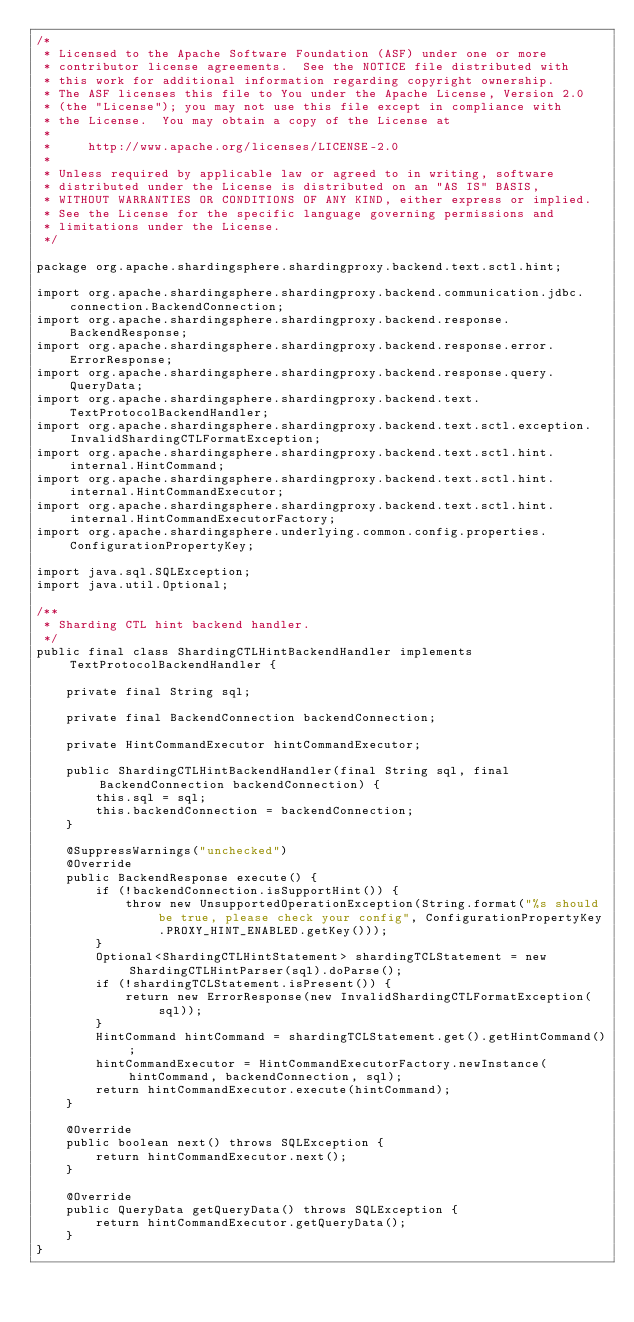Convert code to text. <code><loc_0><loc_0><loc_500><loc_500><_Java_>/*
 * Licensed to the Apache Software Foundation (ASF) under one or more
 * contributor license agreements.  See the NOTICE file distributed with
 * this work for additional information regarding copyright ownership.
 * The ASF licenses this file to You under the Apache License, Version 2.0
 * (the "License"); you may not use this file except in compliance with
 * the License.  You may obtain a copy of the License at
 *
 *     http://www.apache.org/licenses/LICENSE-2.0
 *
 * Unless required by applicable law or agreed to in writing, software
 * distributed under the License is distributed on an "AS IS" BASIS,
 * WITHOUT WARRANTIES OR CONDITIONS OF ANY KIND, either express or implied.
 * See the License for the specific language governing permissions and
 * limitations under the License.
 */

package org.apache.shardingsphere.shardingproxy.backend.text.sctl.hint;

import org.apache.shardingsphere.shardingproxy.backend.communication.jdbc.connection.BackendConnection;
import org.apache.shardingsphere.shardingproxy.backend.response.BackendResponse;
import org.apache.shardingsphere.shardingproxy.backend.response.error.ErrorResponse;
import org.apache.shardingsphere.shardingproxy.backend.response.query.QueryData;
import org.apache.shardingsphere.shardingproxy.backend.text.TextProtocolBackendHandler;
import org.apache.shardingsphere.shardingproxy.backend.text.sctl.exception.InvalidShardingCTLFormatException;
import org.apache.shardingsphere.shardingproxy.backend.text.sctl.hint.internal.HintCommand;
import org.apache.shardingsphere.shardingproxy.backend.text.sctl.hint.internal.HintCommandExecutor;
import org.apache.shardingsphere.shardingproxy.backend.text.sctl.hint.internal.HintCommandExecutorFactory;
import org.apache.shardingsphere.underlying.common.config.properties.ConfigurationPropertyKey;

import java.sql.SQLException;
import java.util.Optional;

/**
 * Sharding CTL hint backend handler.
 */
public final class ShardingCTLHintBackendHandler implements TextProtocolBackendHandler {

    private final String sql;

    private final BackendConnection backendConnection;

    private HintCommandExecutor hintCommandExecutor;

    public ShardingCTLHintBackendHandler(final String sql, final BackendConnection backendConnection) {
        this.sql = sql;
        this.backendConnection = backendConnection;
    }

    @SuppressWarnings("unchecked")
    @Override
    public BackendResponse execute() {
        if (!backendConnection.isSupportHint()) {
            throw new UnsupportedOperationException(String.format("%s should be true, please check your config", ConfigurationPropertyKey.PROXY_HINT_ENABLED.getKey()));
        }
        Optional<ShardingCTLHintStatement> shardingTCLStatement = new ShardingCTLHintParser(sql).doParse();
        if (!shardingTCLStatement.isPresent()) {
            return new ErrorResponse(new InvalidShardingCTLFormatException(sql));
        }
        HintCommand hintCommand = shardingTCLStatement.get().getHintCommand();
        hintCommandExecutor = HintCommandExecutorFactory.newInstance(hintCommand, backendConnection, sql);
        return hintCommandExecutor.execute(hintCommand);
    }

    @Override
    public boolean next() throws SQLException {
        return hintCommandExecutor.next();
    }

    @Override
    public QueryData getQueryData() throws SQLException {
        return hintCommandExecutor.getQueryData();
    }
}
</code> 